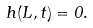Convert formula to latex. <formula><loc_0><loc_0><loc_500><loc_500>h ( L , t ) = 0 .</formula> 